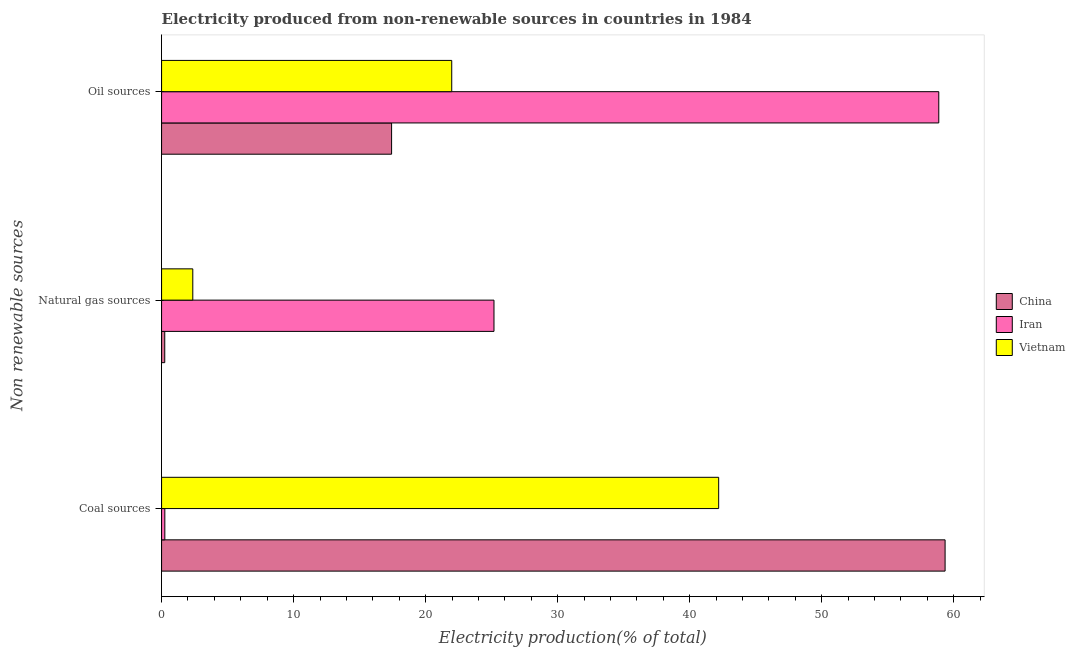How many different coloured bars are there?
Your response must be concise. 3. How many bars are there on the 2nd tick from the top?
Your response must be concise. 3. What is the label of the 1st group of bars from the top?
Keep it short and to the point. Oil sources. What is the percentage of electricity produced by coal in Vietnam?
Provide a short and direct response. 42.19. Across all countries, what is the maximum percentage of electricity produced by coal?
Your answer should be very brief. 59.34. Across all countries, what is the minimum percentage of electricity produced by coal?
Offer a terse response. 0.25. In which country was the percentage of electricity produced by oil sources maximum?
Provide a short and direct response. Iran. In which country was the percentage of electricity produced by natural gas minimum?
Keep it short and to the point. China. What is the total percentage of electricity produced by natural gas in the graph?
Keep it short and to the point. 27.78. What is the difference between the percentage of electricity produced by oil sources in Iran and that in China?
Your answer should be compact. 41.44. What is the difference between the percentage of electricity produced by oil sources in Vietnam and the percentage of electricity produced by coal in China?
Your answer should be very brief. -37.37. What is the average percentage of electricity produced by coal per country?
Ensure brevity in your answer.  33.93. What is the difference between the percentage of electricity produced by oil sources and percentage of electricity produced by coal in China?
Ensure brevity in your answer.  -41.92. In how many countries, is the percentage of electricity produced by natural gas greater than 28 %?
Give a very brief answer. 0. What is the ratio of the percentage of electricity produced by coal in China to that in Vietnam?
Make the answer very short. 1.41. Is the difference between the percentage of electricity produced by oil sources in China and Iran greater than the difference between the percentage of electricity produced by natural gas in China and Iran?
Your answer should be compact. No. What is the difference between the highest and the second highest percentage of electricity produced by natural gas?
Provide a short and direct response. 22.81. What is the difference between the highest and the lowest percentage of electricity produced by natural gas?
Give a very brief answer. 24.94. In how many countries, is the percentage of electricity produced by coal greater than the average percentage of electricity produced by coal taken over all countries?
Provide a succinct answer. 2. What does the 2nd bar from the top in Oil sources represents?
Your answer should be very brief. Iran. What does the 3rd bar from the bottom in Oil sources represents?
Give a very brief answer. Vietnam. Is it the case that in every country, the sum of the percentage of electricity produced by coal and percentage of electricity produced by natural gas is greater than the percentage of electricity produced by oil sources?
Your answer should be compact. No. How many bars are there?
Your answer should be very brief. 9. Are all the bars in the graph horizontal?
Make the answer very short. Yes. What is the difference between two consecutive major ticks on the X-axis?
Offer a very short reply. 10. Where does the legend appear in the graph?
Your response must be concise. Center right. How many legend labels are there?
Ensure brevity in your answer.  3. How are the legend labels stacked?
Your answer should be very brief. Vertical. What is the title of the graph?
Provide a short and direct response. Electricity produced from non-renewable sources in countries in 1984. Does "Poland" appear as one of the legend labels in the graph?
Provide a succinct answer. No. What is the label or title of the X-axis?
Make the answer very short. Electricity production(% of total). What is the label or title of the Y-axis?
Provide a succinct answer. Non renewable sources. What is the Electricity production(% of total) in China in Coal sources?
Offer a very short reply. 59.34. What is the Electricity production(% of total) in Iran in Coal sources?
Your response must be concise. 0.25. What is the Electricity production(% of total) in Vietnam in Coal sources?
Ensure brevity in your answer.  42.19. What is the Electricity production(% of total) of China in Natural gas sources?
Keep it short and to the point. 0.24. What is the Electricity production(% of total) in Iran in Natural gas sources?
Provide a short and direct response. 25.18. What is the Electricity production(% of total) of Vietnam in Natural gas sources?
Keep it short and to the point. 2.37. What is the Electricity production(% of total) of China in Oil sources?
Provide a short and direct response. 17.42. What is the Electricity production(% of total) of Iran in Oil sources?
Your response must be concise. 58.86. What is the Electricity production(% of total) in Vietnam in Oil sources?
Keep it short and to the point. 21.98. Across all Non renewable sources, what is the maximum Electricity production(% of total) of China?
Keep it short and to the point. 59.34. Across all Non renewable sources, what is the maximum Electricity production(% of total) of Iran?
Your answer should be very brief. 58.86. Across all Non renewable sources, what is the maximum Electricity production(% of total) of Vietnam?
Offer a terse response. 42.19. Across all Non renewable sources, what is the minimum Electricity production(% of total) in China?
Offer a terse response. 0.24. Across all Non renewable sources, what is the minimum Electricity production(% of total) of Iran?
Provide a succinct answer. 0.25. Across all Non renewable sources, what is the minimum Electricity production(% of total) of Vietnam?
Offer a very short reply. 2.37. What is the total Electricity production(% of total) in China in the graph?
Give a very brief answer. 77.01. What is the total Electricity production(% of total) of Iran in the graph?
Your response must be concise. 84.29. What is the total Electricity production(% of total) of Vietnam in the graph?
Offer a very short reply. 66.53. What is the difference between the Electricity production(% of total) in China in Coal sources and that in Natural gas sources?
Keep it short and to the point. 59.1. What is the difference between the Electricity production(% of total) in Iran in Coal sources and that in Natural gas sources?
Your answer should be very brief. -24.93. What is the difference between the Electricity production(% of total) in Vietnam in Coal sources and that in Natural gas sources?
Keep it short and to the point. 39.83. What is the difference between the Electricity production(% of total) in China in Coal sources and that in Oil sources?
Make the answer very short. 41.92. What is the difference between the Electricity production(% of total) in Iran in Coal sources and that in Oil sources?
Offer a very short reply. -58.62. What is the difference between the Electricity production(% of total) in Vietnam in Coal sources and that in Oil sources?
Provide a short and direct response. 20.22. What is the difference between the Electricity production(% of total) in China in Natural gas sources and that in Oil sources?
Your answer should be very brief. -17.18. What is the difference between the Electricity production(% of total) in Iran in Natural gas sources and that in Oil sources?
Ensure brevity in your answer.  -33.69. What is the difference between the Electricity production(% of total) of Vietnam in Natural gas sources and that in Oil sources?
Offer a very short reply. -19.61. What is the difference between the Electricity production(% of total) of China in Coal sources and the Electricity production(% of total) of Iran in Natural gas sources?
Offer a terse response. 34.17. What is the difference between the Electricity production(% of total) of China in Coal sources and the Electricity production(% of total) of Vietnam in Natural gas sources?
Provide a short and direct response. 56.98. What is the difference between the Electricity production(% of total) in Iran in Coal sources and the Electricity production(% of total) in Vietnam in Natural gas sources?
Your answer should be very brief. -2.12. What is the difference between the Electricity production(% of total) in China in Coal sources and the Electricity production(% of total) in Iran in Oil sources?
Ensure brevity in your answer.  0.48. What is the difference between the Electricity production(% of total) in China in Coal sources and the Electricity production(% of total) in Vietnam in Oil sources?
Keep it short and to the point. 37.37. What is the difference between the Electricity production(% of total) of Iran in Coal sources and the Electricity production(% of total) of Vietnam in Oil sources?
Your answer should be compact. -21.73. What is the difference between the Electricity production(% of total) of China in Natural gas sources and the Electricity production(% of total) of Iran in Oil sources?
Give a very brief answer. -58.62. What is the difference between the Electricity production(% of total) in China in Natural gas sources and the Electricity production(% of total) in Vietnam in Oil sources?
Provide a succinct answer. -21.73. What is the difference between the Electricity production(% of total) in Iran in Natural gas sources and the Electricity production(% of total) in Vietnam in Oil sources?
Your answer should be very brief. 3.2. What is the average Electricity production(% of total) in China per Non renewable sources?
Give a very brief answer. 25.67. What is the average Electricity production(% of total) in Iran per Non renewable sources?
Your response must be concise. 28.1. What is the average Electricity production(% of total) in Vietnam per Non renewable sources?
Offer a terse response. 22.18. What is the difference between the Electricity production(% of total) in China and Electricity production(% of total) in Iran in Coal sources?
Offer a very short reply. 59.1. What is the difference between the Electricity production(% of total) of China and Electricity production(% of total) of Vietnam in Coal sources?
Make the answer very short. 17.15. What is the difference between the Electricity production(% of total) in Iran and Electricity production(% of total) in Vietnam in Coal sources?
Keep it short and to the point. -41.95. What is the difference between the Electricity production(% of total) in China and Electricity production(% of total) in Iran in Natural gas sources?
Keep it short and to the point. -24.94. What is the difference between the Electricity production(% of total) of China and Electricity production(% of total) of Vietnam in Natural gas sources?
Provide a succinct answer. -2.12. What is the difference between the Electricity production(% of total) of Iran and Electricity production(% of total) of Vietnam in Natural gas sources?
Ensure brevity in your answer.  22.81. What is the difference between the Electricity production(% of total) in China and Electricity production(% of total) in Iran in Oil sources?
Offer a very short reply. -41.44. What is the difference between the Electricity production(% of total) in China and Electricity production(% of total) in Vietnam in Oil sources?
Make the answer very short. -4.55. What is the difference between the Electricity production(% of total) in Iran and Electricity production(% of total) in Vietnam in Oil sources?
Make the answer very short. 36.89. What is the ratio of the Electricity production(% of total) of China in Coal sources to that in Natural gas sources?
Offer a terse response. 246.37. What is the ratio of the Electricity production(% of total) of Iran in Coal sources to that in Natural gas sources?
Offer a terse response. 0.01. What is the ratio of the Electricity production(% of total) of Vietnam in Coal sources to that in Natural gas sources?
Keep it short and to the point. 17.84. What is the ratio of the Electricity production(% of total) in China in Coal sources to that in Oil sources?
Ensure brevity in your answer.  3.41. What is the ratio of the Electricity production(% of total) of Iran in Coal sources to that in Oil sources?
Offer a terse response. 0. What is the ratio of the Electricity production(% of total) of Vietnam in Coal sources to that in Oil sources?
Your answer should be compact. 1.92. What is the ratio of the Electricity production(% of total) in China in Natural gas sources to that in Oil sources?
Your response must be concise. 0.01. What is the ratio of the Electricity production(% of total) in Iran in Natural gas sources to that in Oil sources?
Your response must be concise. 0.43. What is the ratio of the Electricity production(% of total) of Vietnam in Natural gas sources to that in Oil sources?
Give a very brief answer. 0.11. What is the difference between the highest and the second highest Electricity production(% of total) of China?
Offer a terse response. 41.92. What is the difference between the highest and the second highest Electricity production(% of total) of Iran?
Give a very brief answer. 33.69. What is the difference between the highest and the second highest Electricity production(% of total) of Vietnam?
Offer a very short reply. 20.22. What is the difference between the highest and the lowest Electricity production(% of total) of China?
Your response must be concise. 59.1. What is the difference between the highest and the lowest Electricity production(% of total) of Iran?
Your answer should be compact. 58.62. What is the difference between the highest and the lowest Electricity production(% of total) in Vietnam?
Make the answer very short. 39.83. 